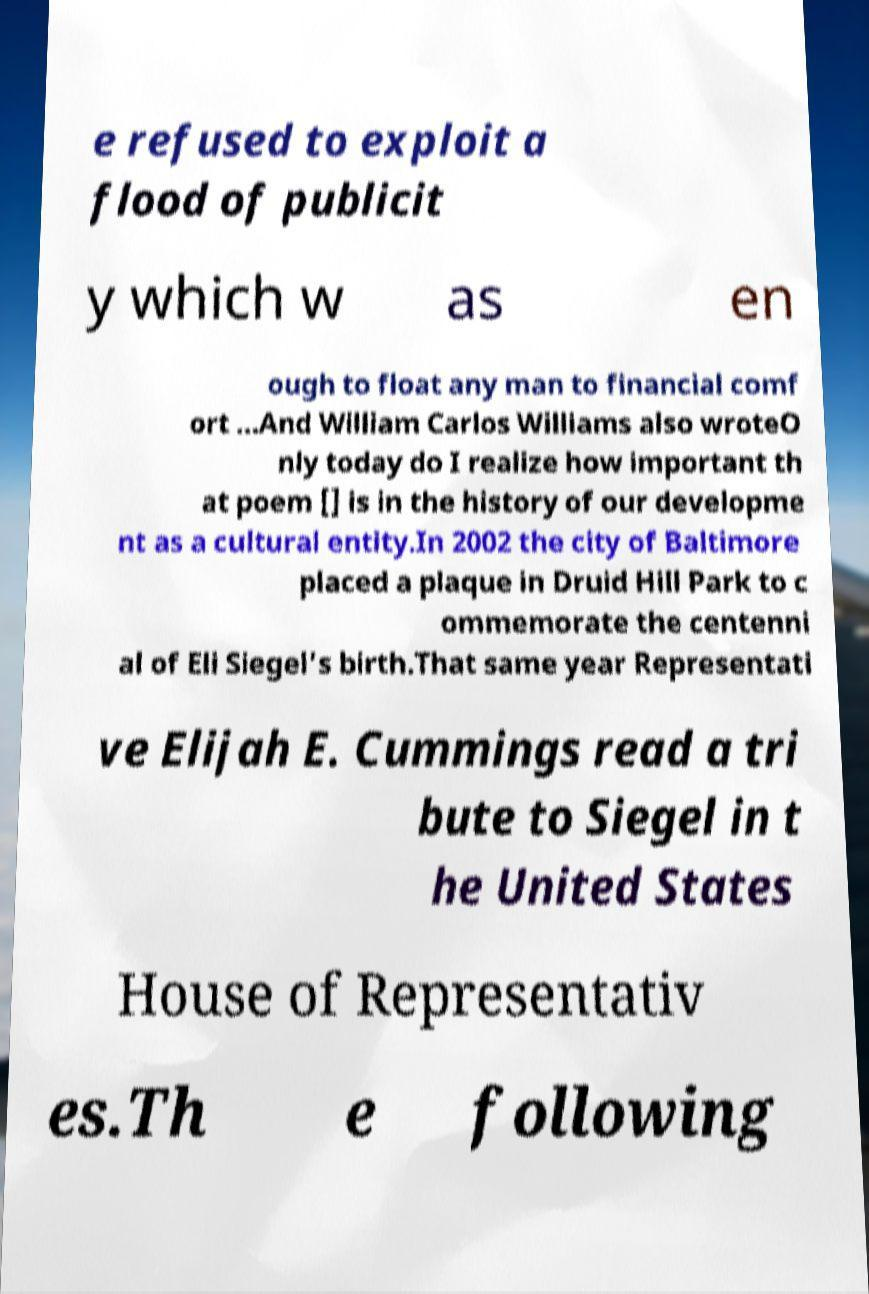Please read and relay the text visible in this image. What does it say? e refused to exploit a flood of publicit y which w as en ough to float any man to financial comf ort ...And William Carlos Williams also wroteO nly today do I realize how important th at poem [] is in the history of our developme nt as a cultural entity.In 2002 the city of Baltimore placed a plaque in Druid Hill Park to c ommemorate the centenni al of Eli Siegel's birth.That same year Representati ve Elijah E. Cummings read a tri bute to Siegel in t he United States House of Representativ es.Th e following 